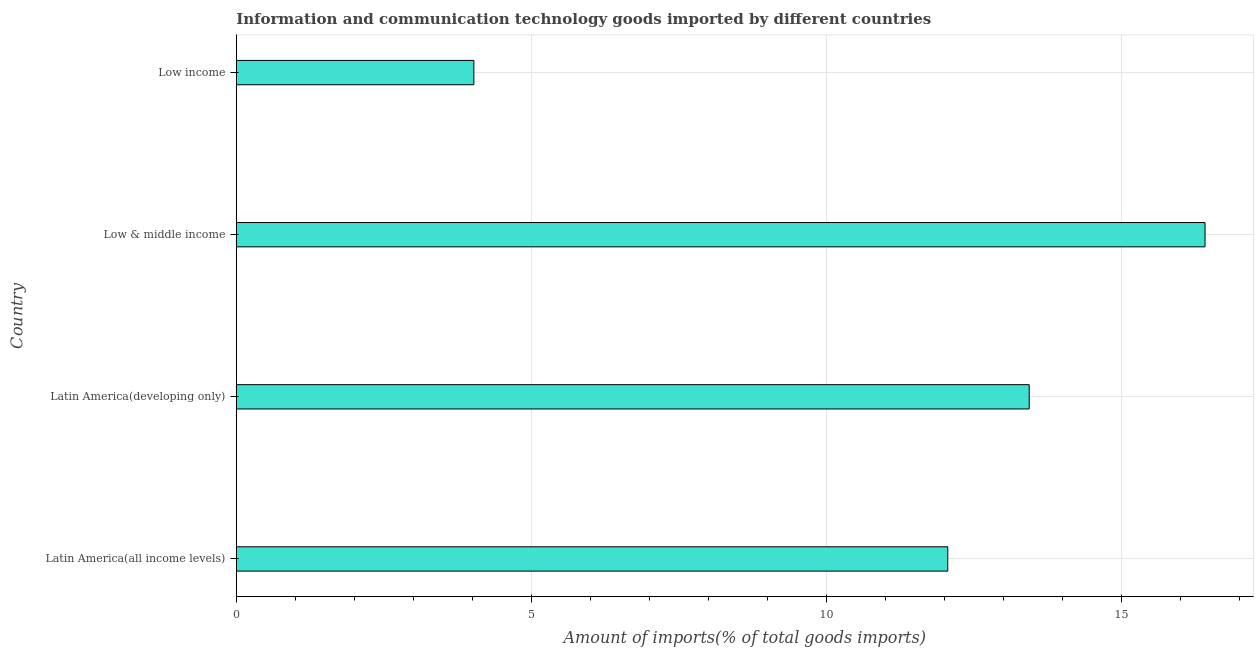Does the graph contain any zero values?
Your response must be concise. No. Does the graph contain grids?
Make the answer very short. Yes. What is the title of the graph?
Keep it short and to the point. Information and communication technology goods imported by different countries. What is the label or title of the X-axis?
Your response must be concise. Amount of imports(% of total goods imports). What is the amount of ict goods imports in Latin America(all income levels)?
Make the answer very short. 12.06. Across all countries, what is the maximum amount of ict goods imports?
Offer a very short reply. 16.42. Across all countries, what is the minimum amount of ict goods imports?
Give a very brief answer. 4.03. In which country was the amount of ict goods imports minimum?
Provide a succinct answer. Low income. What is the sum of the amount of ict goods imports?
Provide a short and direct response. 45.96. What is the difference between the amount of ict goods imports in Latin America(all income levels) and Low income?
Offer a very short reply. 8.03. What is the average amount of ict goods imports per country?
Make the answer very short. 11.49. What is the median amount of ict goods imports?
Your response must be concise. 12.75. In how many countries, is the amount of ict goods imports greater than 6 %?
Ensure brevity in your answer.  3. What is the ratio of the amount of ict goods imports in Latin America(all income levels) to that in Low income?
Your answer should be compact. 2.99. Is the difference between the amount of ict goods imports in Latin America(developing only) and Low income greater than the difference between any two countries?
Provide a short and direct response. No. What is the difference between the highest and the second highest amount of ict goods imports?
Your answer should be very brief. 2.98. What is the difference between the highest and the lowest amount of ict goods imports?
Your response must be concise. 12.4. In how many countries, is the amount of ict goods imports greater than the average amount of ict goods imports taken over all countries?
Your answer should be very brief. 3. How many bars are there?
Offer a very short reply. 4. How many countries are there in the graph?
Keep it short and to the point. 4. What is the difference between two consecutive major ticks on the X-axis?
Your answer should be very brief. 5. What is the Amount of imports(% of total goods imports) of Latin America(all income levels)?
Your answer should be very brief. 12.06. What is the Amount of imports(% of total goods imports) in Latin America(developing only)?
Ensure brevity in your answer.  13.44. What is the Amount of imports(% of total goods imports) in Low & middle income?
Ensure brevity in your answer.  16.42. What is the Amount of imports(% of total goods imports) of Low income?
Make the answer very short. 4.03. What is the difference between the Amount of imports(% of total goods imports) in Latin America(all income levels) and Latin America(developing only)?
Give a very brief answer. -1.38. What is the difference between the Amount of imports(% of total goods imports) in Latin America(all income levels) and Low & middle income?
Offer a very short reply. -4.36. What is the difference between the Amount of imports(% of total goods imports) in Latin America(all income levels) and Low income?
Your answer should be very brief. 8.03. What is the difference between the Amount of imports(% of total goods imports) in Latin America(developing only) and Low & middle income?
Give a very brief answer. -2.98. What is the difference between the Amount of imports(% of total goods imports) in Latin America(developing only) and Low income?
Provide a succinct answer. 9.41. What is the difference between the Amount of imports(% of total goods imports) in Low & middle income and Low income?
Your response must be concise. 12.4. What is the ratio of the Amount of imports(% of total goods imports) in Latin America(all income levels) to that in Latin America(developing only)?
Give a very brief answer. 0.9. What is the ratio of the Amount of imports(% of total goods imports) in Latin America(all income levels) to that in Low & middle income?
Keep it short and to the point. 0.73. What is the ratio of the Amount of imports(% of total goods imports) in Latin America(all income levels) to that in Low income?
Ensure brevity in your answer.  2.99. What is the ratio of the Amount of imports(% of total goods imports) in Latin America(developing only) to that in Low & middle income?
Your response must be concise. 0.82. What is the ratio of the Amount of imports(% of total goods imports) in Latin America(developing only) to that in Low income?
Your answer should be compact. 3.34. What is the ratio of the Amount of imports(% of total goods imports) in Low & middle income to that in Low income?
Provide a succinct answer. 4.08. 